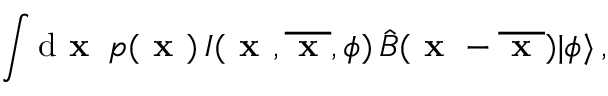<formula> <loc_0><loc_0><loc_500><loc_500>\int d x \, p ( x ) \, I ( x , \overline { x } , \phi ) \, \hat { B } ( x - \overline { x } ) | \phi \rangle \, ,</formula> 